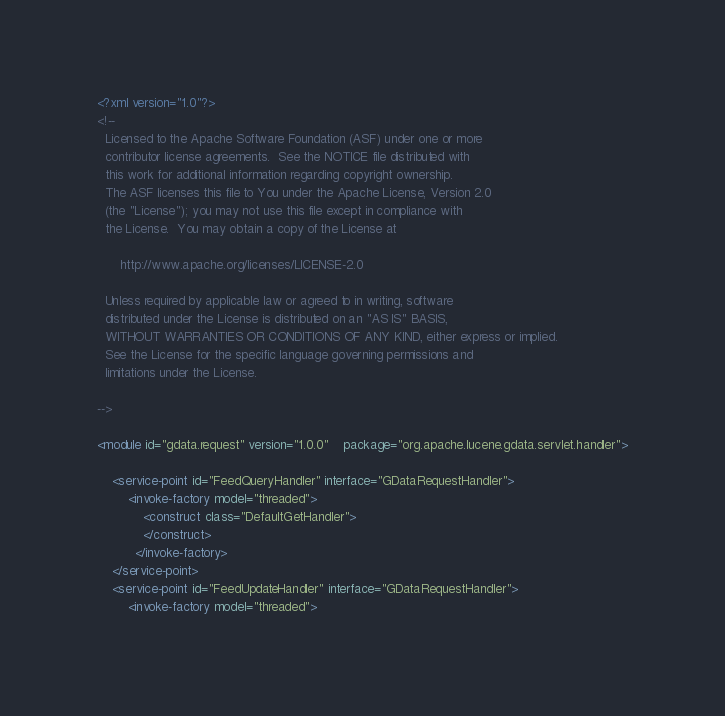<code> <loc_0><loc_0><loc_500><loc_500><_XML_><?xml version="1.0"?>
<!-- 
  Licensed to the Apache Software Foundation (ASF) under one or more
  contributor license agreements.  See the NOTICE file distributed with
  this work for additional information regarding copyright ownership.
  The ASF licenses this file to You under the Apache License, Version 2.0
  (the "License"); you may not use this file except in compliance with
  the License.  You may obtain a copy of the License at
 
      http://www.apache.org/licenses/LICENSE-2.0
 
  Unless required by applicable law or agreed to in writing, software
  distributed under the License is distributed on an "AS IS" BASIS,
  WITHOUT WARRANTIES OR CONDITIONS OF ANY KIND, either express or implied.
  See the License for the specific language governing permissions and
  limitations under the License.
 
-->

<module id="gdata.request" version="1.0.0"	package="org.apache.lucene.gdata.servlet.handler">
	
	<service-point id="FeedQueryHandler" interface="GDataRequestHandler">
 		<invoke-factory model="threaded">
			<construct class="DefaultGetHandler">
			</construct>
		  </invoke-factory>
	</service-point>
	<service-point id="FeedUpdateHandler" interface="GDataRequestHandler">
 		<invoke-factory model="threaded"></code> 